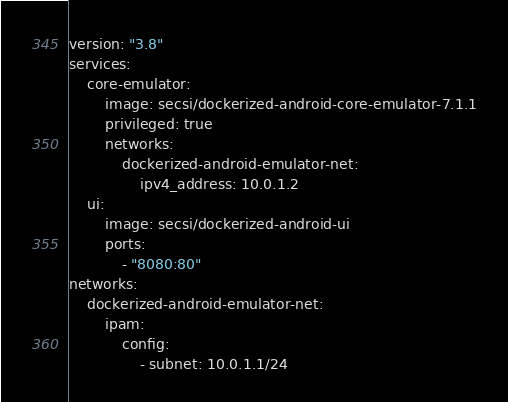<code> <loc_0><loc_0><loc_500><loc_500><_YAML_>version: "3.8"
services:
    core-emulator:
        image: secsi/dockerized-android-core-emulator-7.1.1
        privileged: true
        networks:
            dockerized-android-emulator-net:
                ipv4_address: 10.0.1.2
    ui:
        image: secsi/dockerized-android-ui
        ports:
            - "8080:80"
networks:
    dockerized-android-emulator-net:
        ipam:
            config:
                - subnet: 10.0.1.1/24
</code> 